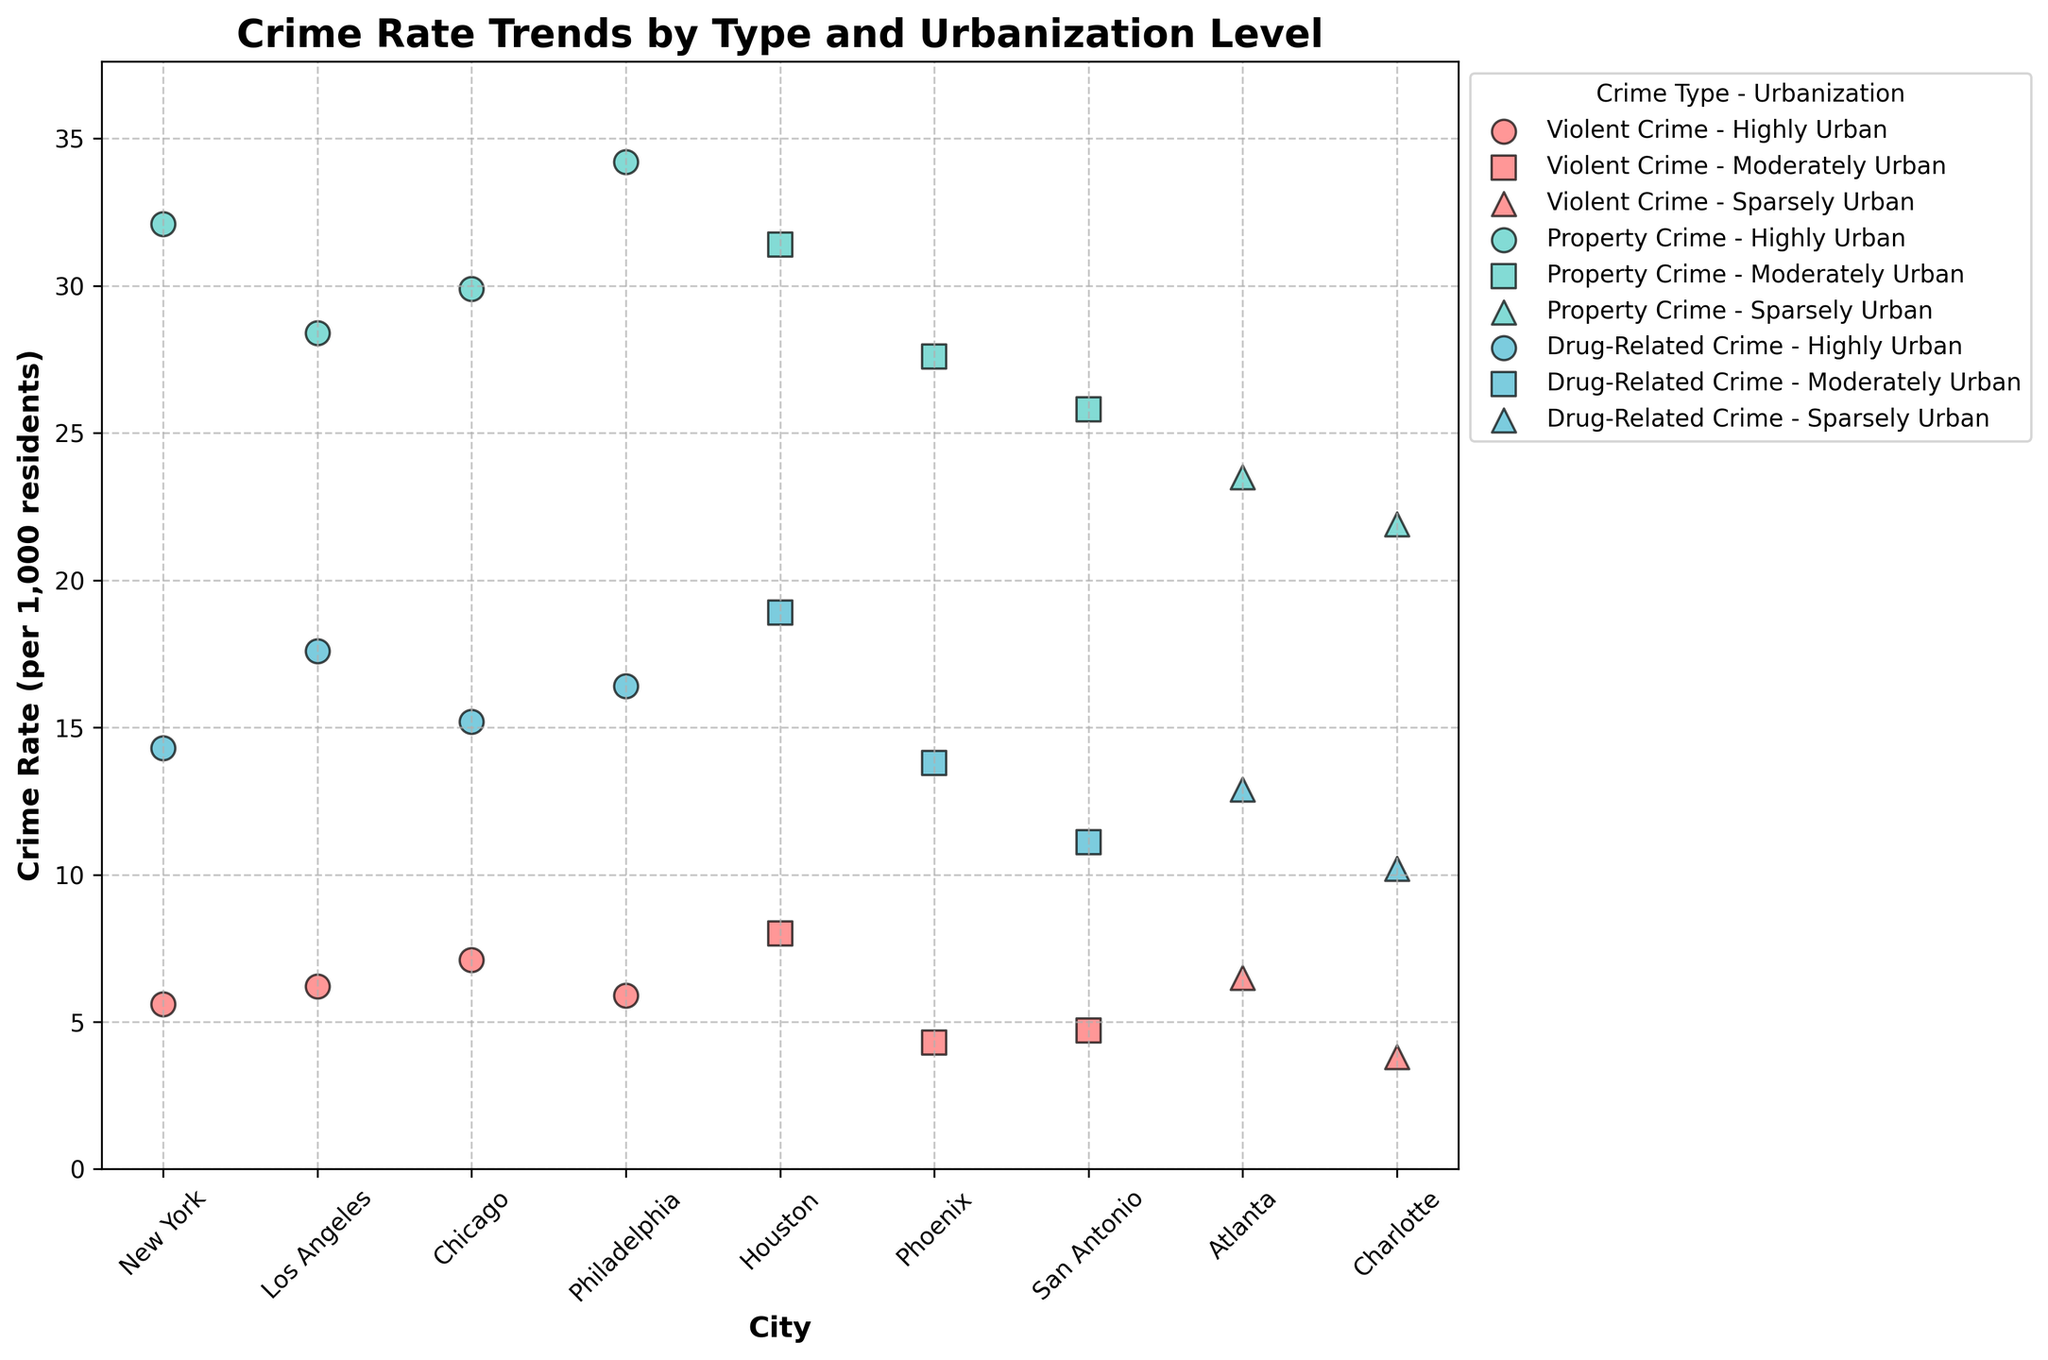What is the title of the plot? The title of the plot is usually located at the top of the figure. In this case, it is "Crime Rate Trends by Type and Urbanization Level".
Answer: Crime Rate Trends by Type and Urbanization Level Which city has the highest violent crime rate? By looking at the data points representing violent crime across all cities, the city with the highest value should be identified. Houston has a violent crime rate of 8.0, which is the highest.
Answer: Houston How many unique urbanization levels are depicted in the plot? The legend or the color/marker distinctions help identify the unique urbanization levels. The data shows three levels: Highly Urban, Moderately Urban, and Sparsely Urban.
Answer: Three Which city has the lowest property crime rate and what is it? By identifying the property crime data points, we look for the smallest value. Charlotte has a property crime rate of 21.9 per 1,000 residents.
Answer: Charlotte, 21.9 What is the median drug-related crime rate among all cities? Arrange all drug-related crime rates in ascending order and find the middle value. Rates are 10.2, 11.1, 12.9, 13.8, 14.3, 15.2, 16.4, 17.6, 18.9. The middle value is 14.3.
Answer: 14.3 Between Violent and Property Crime in highly urban cities, which type generally has higher crime rates? By comparing the general trend of data points for Violent and Property Crime in highly urban cities (New York, Los Angeles, Chicago, Philadelphia), Property Crime rates are consistently higher than Violent Crime rates.
Answer: Property Crime Which city shows the largest difference between property crime and drug-related crime rates? Calculate the difference between property and drug-related crime for each city and compare them. Houston shows the largest difference of \(31.4 - 18.9 = 12.5\).
Answer: Houston, 12.5 How do crime rates vary by urbanization level for Violent Crimes? By examining the violent crime data points grouped by urbanization level, the trend can be summarized. Highly urban cities have rates around 5.6 to 7.1, moderately urban cities around 4.3 to 8.0, and sparsely urban cities around 3.8 to 6.5.
Answer: Rates are moderately varied with some overlaps 